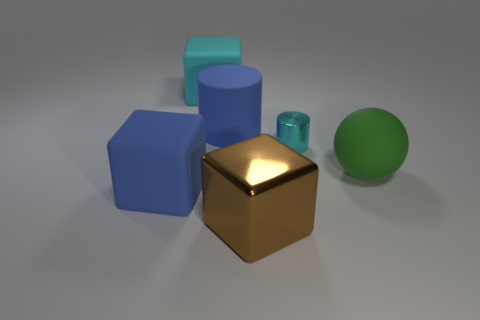What could the green sphere be used for in this arrangement? The green sphere in the image, by its lone presence and simplicity, could represent a multitude of things. It could be depicting a basic geometric shape in a tutorial, representing a ball in a minimalist setting, or used as a simple, abstract focal point in a piece of digital art. 